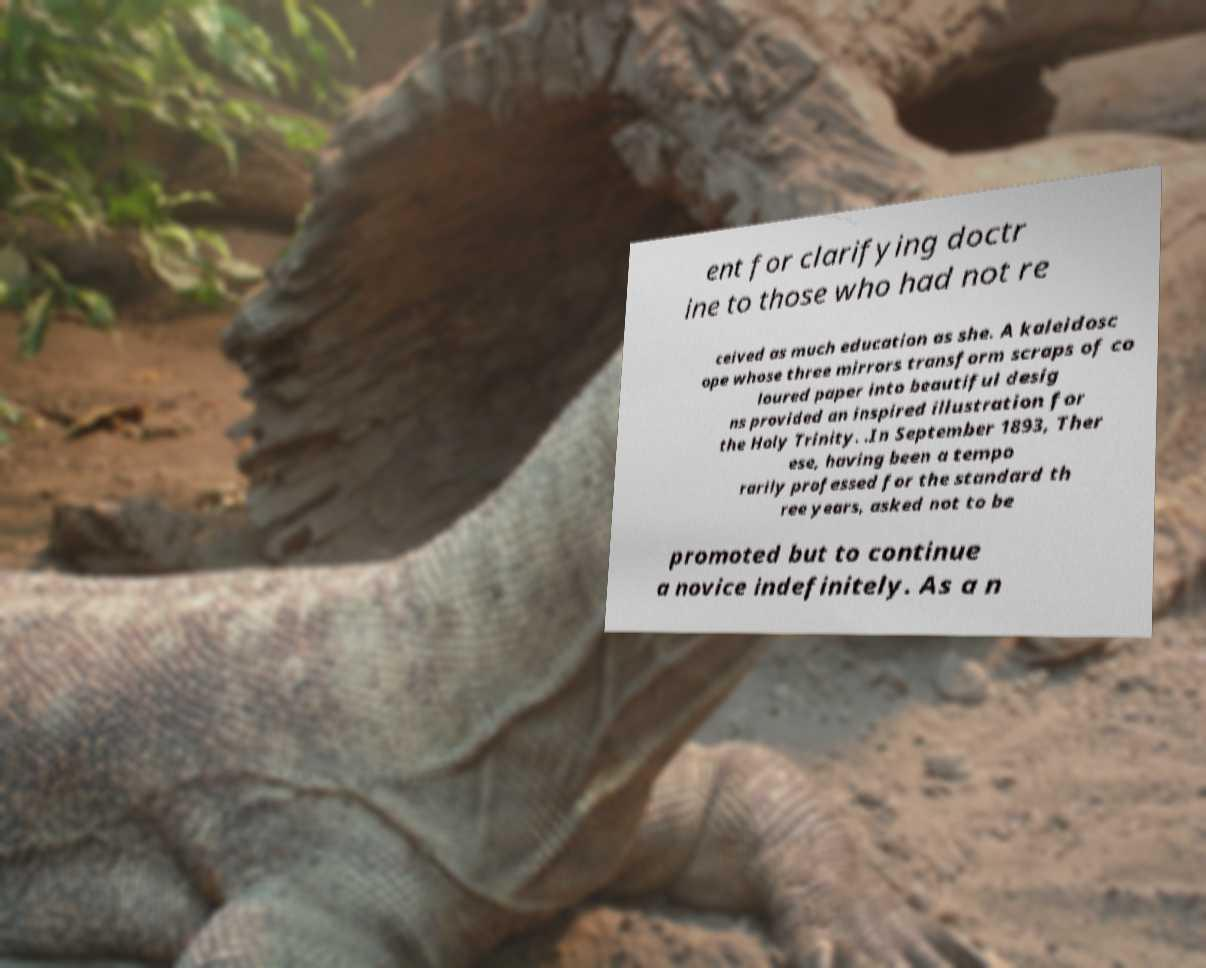Please identify and transcribe the text found in this image. ent for clarifying doctr ine to those who had not re ceived as much education as she. A kaleidosc ope whose three mirrors transform scraps of co loured paper into beautiful desig ns provided an inspired illustration for the Holy Trinity. .In September 1893, Ther ese, having been a tempo rarily professed for the standard th ree years, asked not to be promoted but to continue a novice indefinitely. As a n 